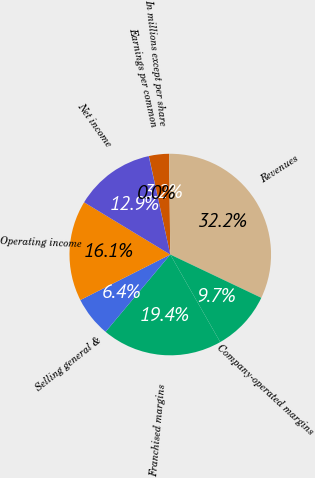Convert chart to OTSL. <chart><loc_0><loc_0><loc_500><loc_500><pie_chart><fcel>In millions except per share<fcel>Revenues<fcel>Company-operated margins<fcel>Franchised margins<fcel>Selling general &<fcel>Operating income<fcel>Net income<fcel>Earnings per common<nl><fcel>3.23%<fcel>32.25%<fcel>9.68%<fcel>19.35%<fcel>6.45%<fcel>16.13%<fcel>12.9%<fcel>0.01%<nl></chart> 